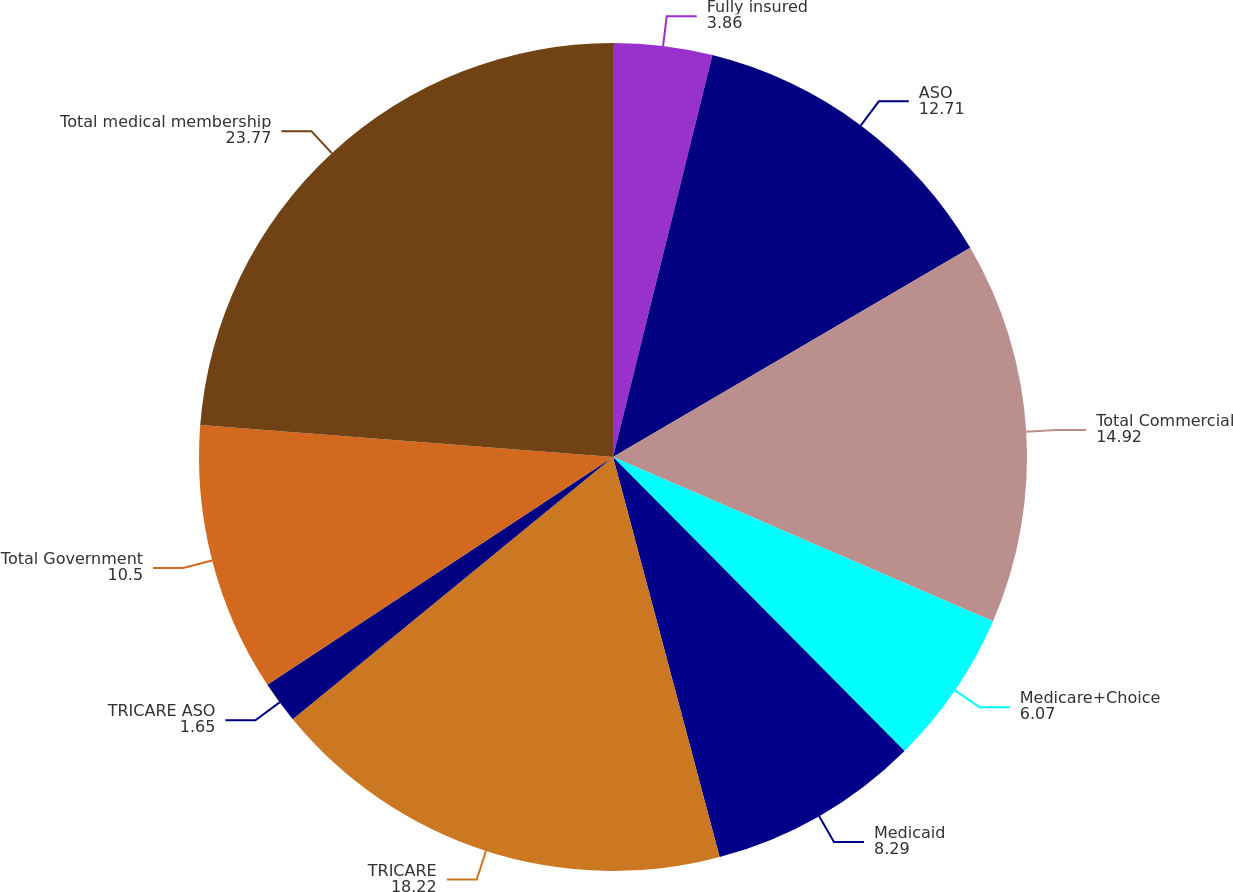Convert chart to OTSL. <chart><loc_0><loc_0><loc_500><loc_500><pie_chart><fcel>Fully insured<fcel>ASO<fcel>Total Commercial<fcel>Medicare+Choice<fcel>Medicaid<fcel>TRICARE<fcel>TRICARE ASO<fcel>Total Government<fcel>Total medical membership<nl><fcel>3.86%<fcel>12.71%<fcel>14.92%<fcel>6.07%<fcel>8.29%<fcel>18.22%<fcel>1.65%<fcel>10.5%<fcel>23.77%<nl></chart> 